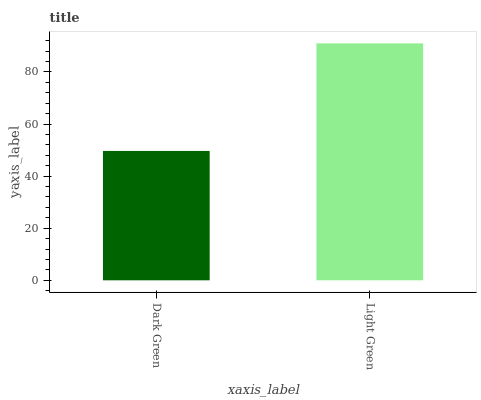Is Light Green the maximum?
Answer yes or no. Yes. Is Light Green the minimum?
Answer yes or no. No. Is Light Green greater than Dark Green?
Answer yes or no. Yes. Is Dark Green less than Light Green?
Answer yes or no. Yes. Is Dark Green greater than Light Green?
Answer yes or no. No. Is Light Green less than Dark Green?
Answer yes or no. No. Is Light Green the high median?
Answer yes or no. Yes. Is Dark Green the low median?
Answer yes or no. Yes. Is Dark Green the high median?
Answer yes or no. No. Is Light Green the low median?
Answer yes or no. No. 